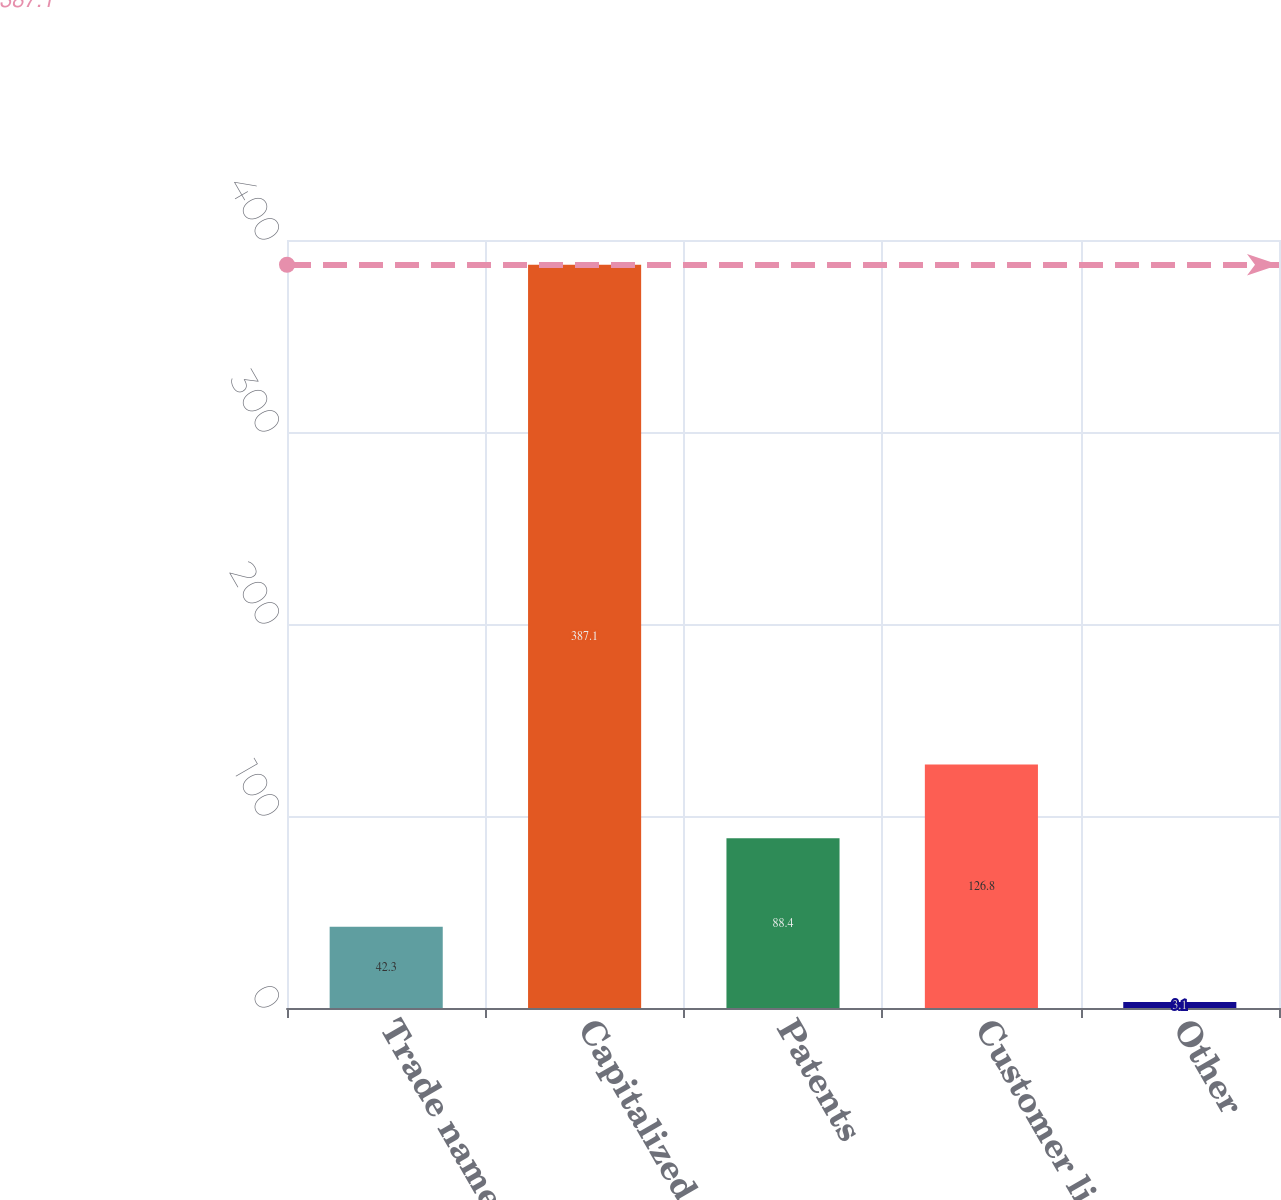Convert chart to OTSL. <chart><loc_0><loc_0><loc_500><loc_500><bar_chart><fcel>Trade names - other<fcel>Capitalized software<fcel>Patents<fcel>Customer lists<fcel>Other<nl><fcel>42.3<fcel>387.1<fcel>88.4<fcel>126.8<fcel>3.1<nl></chart> 